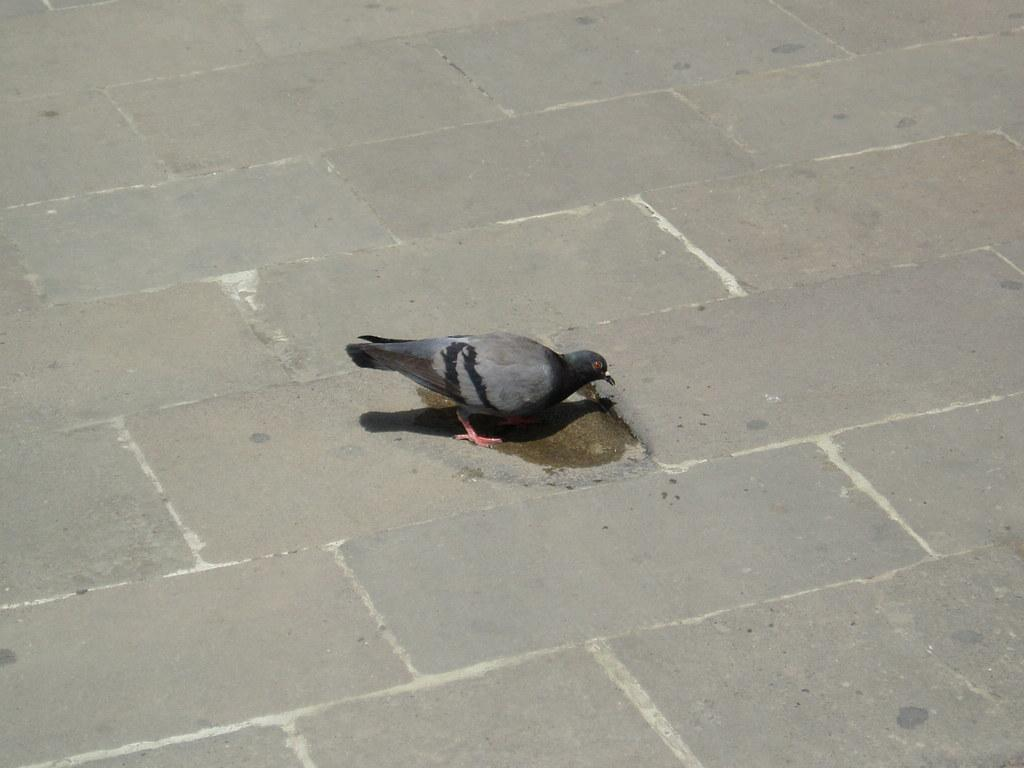What type of animal is in the image? There is a pigeon in the image. Where is the pigeon located in the image? The pigeon is in the center of the image. What type of apparel is the pigeon wearing in the image? The pigeon is not wearing any apparel in the image. What act is the pigeon performing in the image? The pigeon is not performing any specific act in the image; it is simply present in the center. 